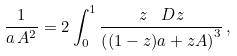Convert formula to latex. <formula><loc_0><loc_0><loc_500><loc_500>\frac { 1 } { a \, A ^ { 2 } } = 2 \int _ { 0 } ^ { 1 } \frac { z \, \ D z } { \left ( ( 1 - z ) a + z A \right ) ^ { 3 } } \, ,</formula> 